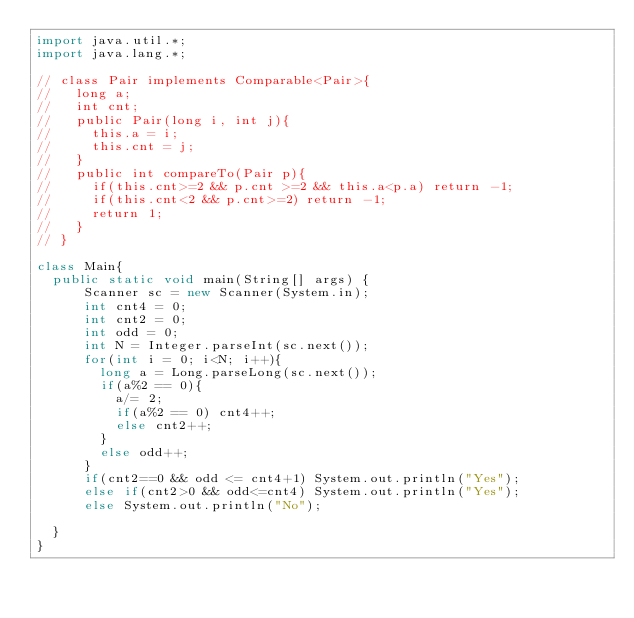<code> <loc_0><loc_0><loc_500><loc_500><_Java_>import java.util.*;
import java.lang.*;

// class Pair implements Comparable<Pair>{
//   long a;
//   int cnt;
//   public Pair(long i, int j){
//     this.a = i;
//     this.cnt = j;
//   }
//   public int compareTo(Pair p){
//     if(this.cnt>=2 && p.cnt >=2 && this.a<p.a) return -1;
//     if(this.cnt<2 && p.cnt>=2) return -1;
//     return 1;
//   }
// }

class Main{
  public static void main(String[] args) {
      Scanner sc = new Scanner(System.in);
      int cnt4 = 0;
      int cnt2 = 0;
      int odd = 0;
      int N = Integer.parseInt(sc.next());
      for(int i = 0; i<N; i++){
        long a = Long.parseLong(sc.next());
        if(a%2 == 0){
          a/= 2;
          if(a%2 == 0) cnt4++;
          else cnt2++;
        }
        else odd++;
      }
      if(cnt2==0 && odd <= cnt4+1) System.out.println("Yes");
      else if(cnt2>0 && odd<=cnt4) System.out.println("Yes");
      else System.out.println("No");

  }
}</code> 